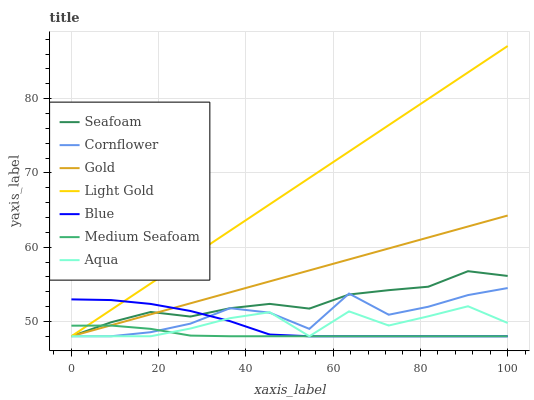Does Medium Seafoam have the minimum area under the curve?
Answer yes or no. Yes. Does Light Gold have the maximum area under the curve?
Answer yes or no. Yes. Does Cornflower have the minimum area under the curve?
Answer yes or no. No. Does Cornflower have the maximum area under the curve?
Answer yes or no. No. Is Gold the smoothest?
Answer yes or no. Yes. Is Cornflower the roughest?
Answer yes or no. Yes. Is Cornflower the smoothest?
Answer yes or no. No. Is Gold the roughest?
Answer yes or no. No. Does Blue have the lowest value?
Answer yes or no. Yes. Does Light Gold have the highest value?
Answer yes or no. Yes. Does Cornflower have the highest value?
Answer yes or no. No. Does Light Gold intersect Cornflower?
Answer yes or no. Yes. Is Light Gold less than Cornflower?
Answer yes or no. No. Is Light Gold greater than Cornflower?
Answer yes or no. No. 